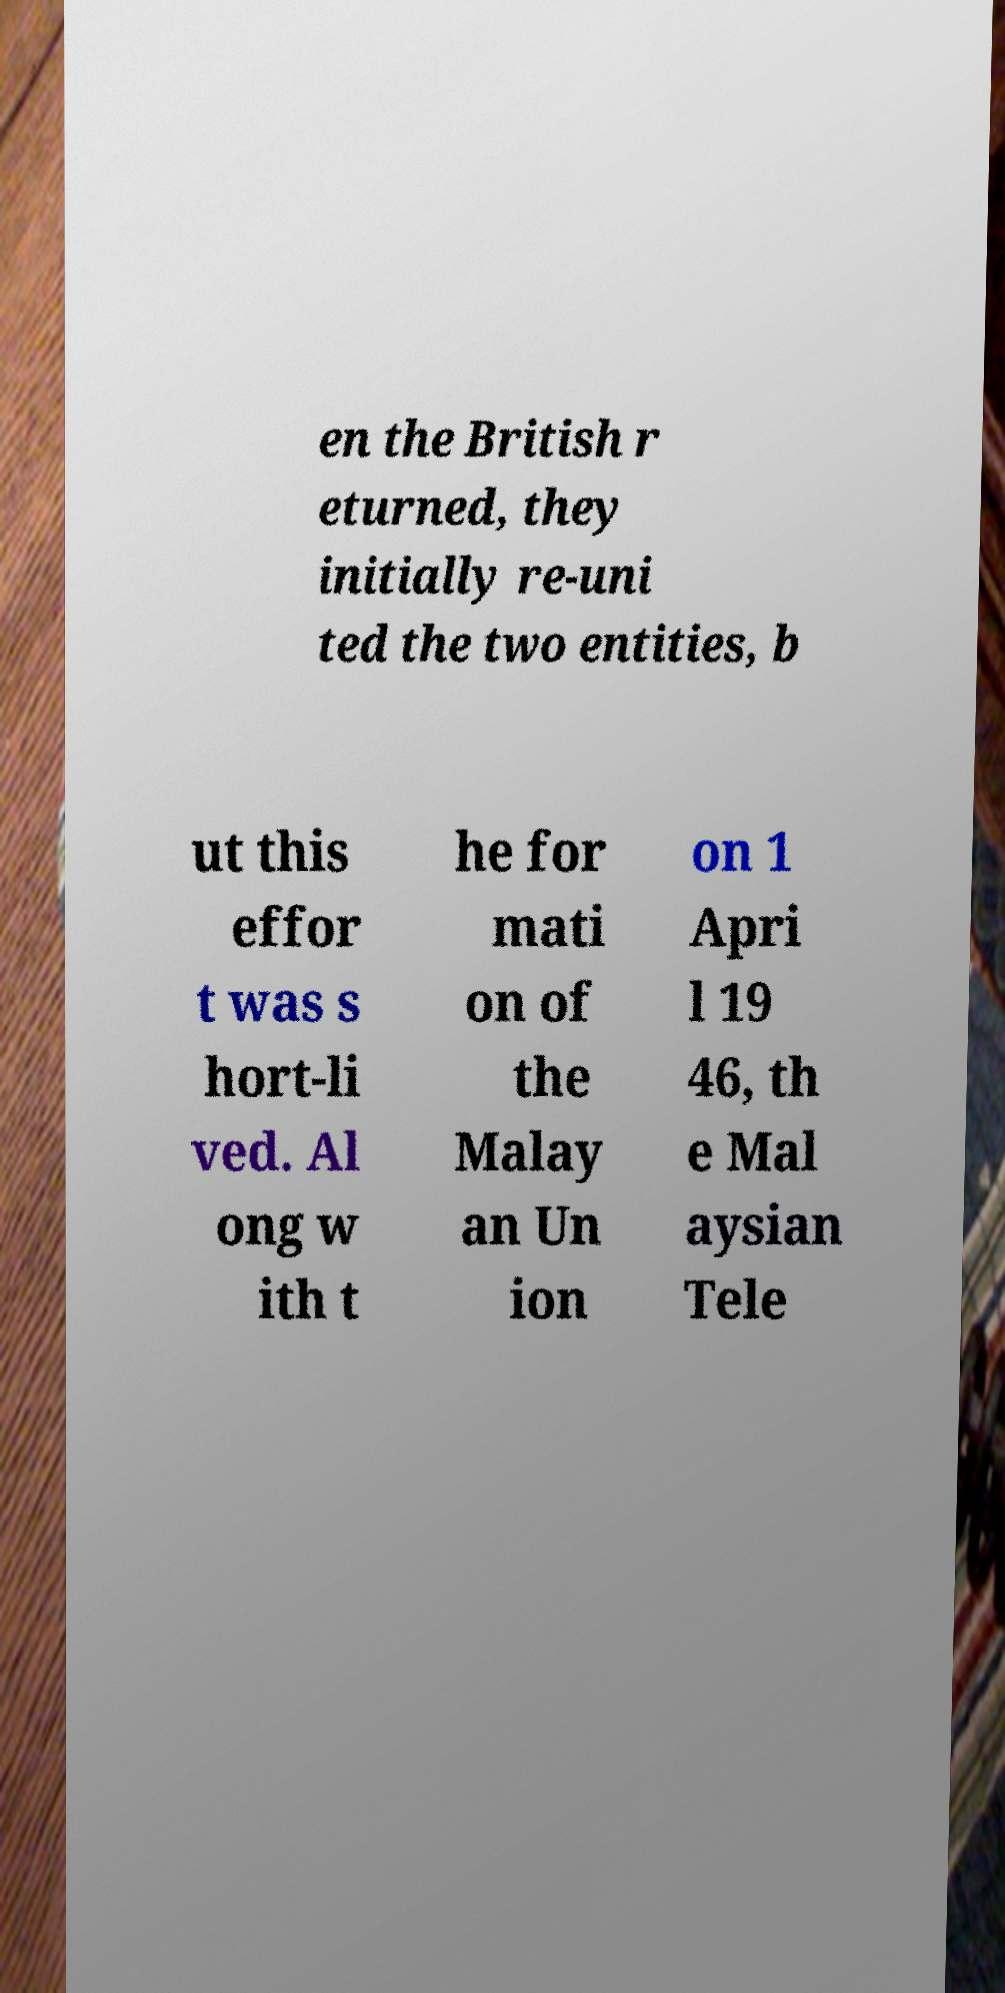For documentation purposes, I need the text within this image transcribed. Could you provide that? en the British r eturned, they initially re-uni ted the two entities, b ut this effor t was s hort-li ved. Al ong w ith t he for mati on of the Malay an Un ion on 1 Apri l 19 46, th e Mal aysian Tele 